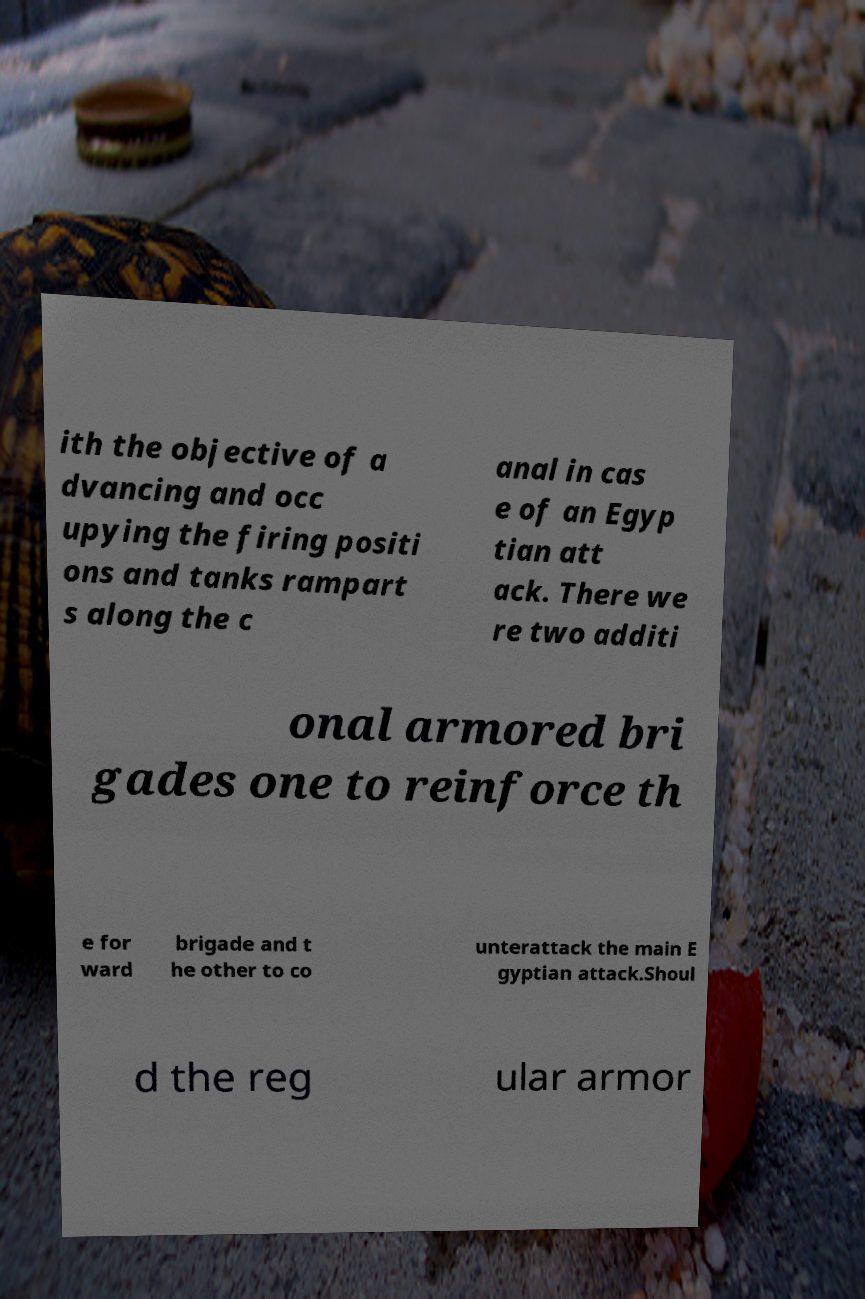There's text embedded in this image that I need extracted. Can you transcribe it verbatim? ith the objective of a dvancing and occ upying the firing positi ons and tanks rampart s along the c anal in cas e of an Egyp tian att ack. There we re two additi onal armored bri gades one to reinforce th e for ward brigade and t he other to co unterattack the main E gyptian attack.Shoul d the reg ular armor 